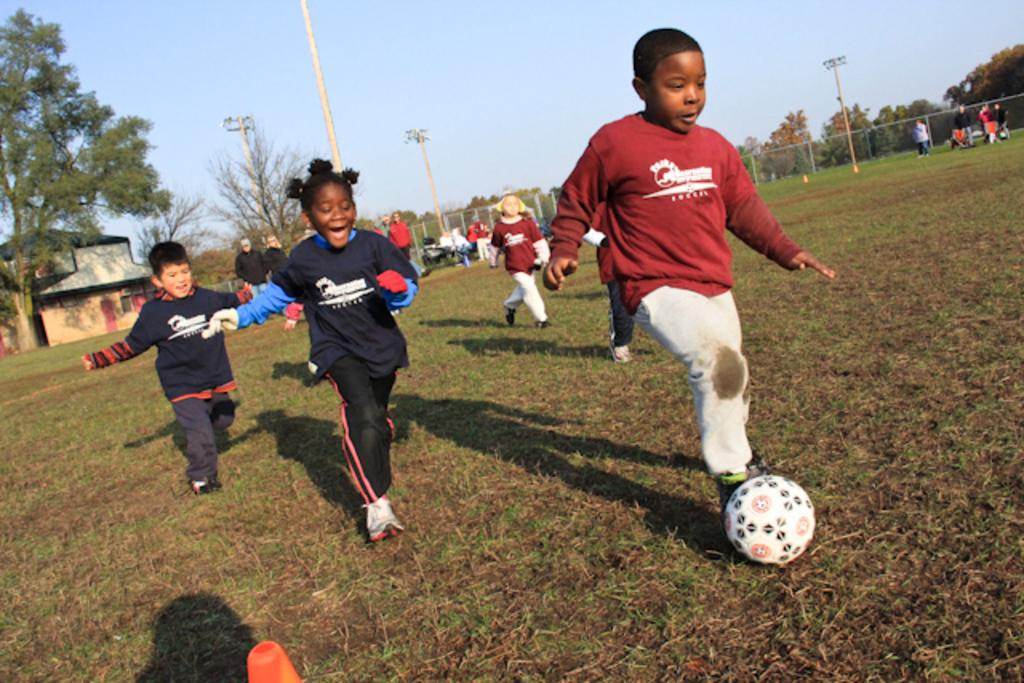What is happening in the image involving the group of kids? The kids are playing football in the image. What can be seen in the background of the image? There are trees in the background of the image. How is the ground described in the image? The ground is covered in greenery. What type of chalk is being used by the kids to draw on the football? There is no chalk present in the image, and the kids are playing football, not drawing on it. 